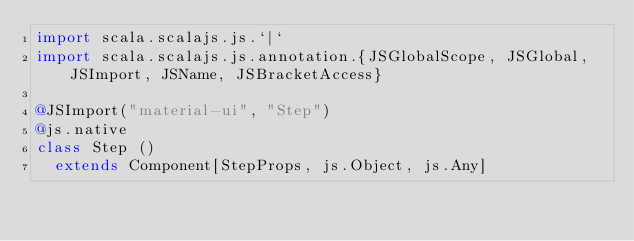<code> <loc_0><loc_0><loc_500><loc_500><_Scala_>import scala.scalajs.js.`|`
import scala.scalajs.js.annotation.{JSGlobalScope, JSGlobal, JSImport, JSName, JSBracketAccess}

@JSImport("material-ui", "Step")
@js.native
class Step ()
  extends Component[StepProps, js.Object, js.Any]
</code> 